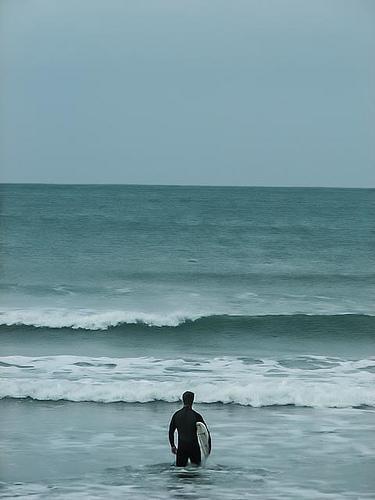How many people are in the picture?
Give a very brief answer. 1. 